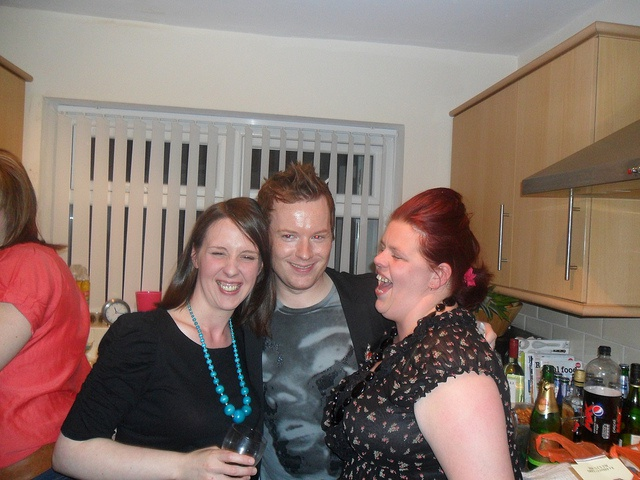Describe the objects in this image and their specific colors. I can see people in gray, black, lightpink, and darkgray tones, people in gray, black, lightpink, maroon, and pink tones, people in gray, black, darkgray, and lightpink tones, people in gray, brown, and maroon tones, and bottle in gray, black, darkgray, and maroon tones in this image. 